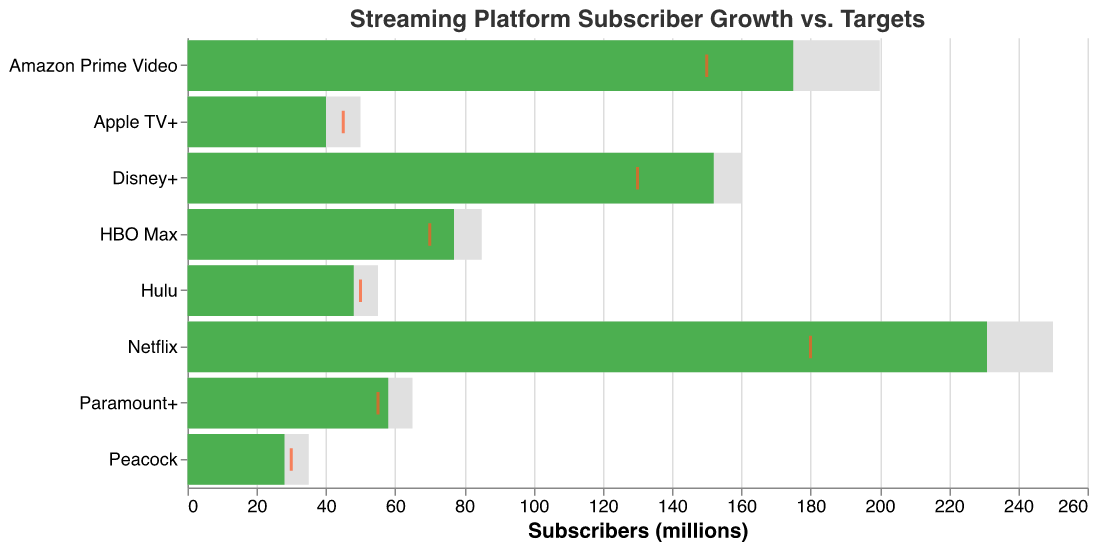What is the title of the chart? The title is located at the top and usually summarizes the information in the chart. In this case, it says "Streaming Platform Subscriber Growth vs. Targets".
Answer: Streaming Platform Subscriber Growth vs. Targets Which streaming platform has the highest actual number of subscribers? By looking at the longest green bar (representing actual subscribers), we see that Netflix has the highest actual number of subscribers.
Answer: Netflix How many platforms have actual subscribers exceeding the industry average? We compare the length of the green bars (actual subscribers) to the positions of the orange ticks (industry average). Netflix, Disney+, Amazon Prime Video, HBO Max, and Paramount+ have actual subscribers above the industry average.
Answer: 5 What is the difference between the actual and target subscribers for Netflix? Look at the values for Netflix. Subtract the actual subscribers (231 million) from the target subscribers (250 million). The difference is 250 - 231 = 19 million.
Answer: 19 million How does Apple TV+ perform compared to its target and the industry average? Apple TV+ has 40 million actual subscribers, 50 million target subscribers, and the industry average is 45 million. Actual is less than both target and industry average.
Answer: Below both target and average Which platform most closely meets its target number of subscribers? Check the green bars' lengths against the grey bars' lengths. Disney+ has 152 million actual subscribers vs. 160 million target subscribers. The difference is 8 million, the smallest among all platforms.
Answer: Disney+ How many platforms have actual subscribers below 50 million? Count the green bars that are below the 50 million mark. Apple TV+, Hulu, Peacock, and HBO Max are below 50 million.
Answer: 4 What is the total number of actual subscribers across all platforms? Sum the actual subscribers for all platforms: 231 + 152 + 175 + 77 + 40 + 48 + 28 + 58 = 809 million.
Answer: 809 million Which platform has the smallest gap between its target and actual subscribers? Determine the differences for each platform by subtracting actual from target. Disney+ has the smallest gap: 160 - 152 = 8 million.
Answer: Disney+ 